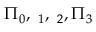Convert formula to latex. <formula><loc_0><loc_0><loc_500><loc_500>\Pi _ { 0 } , { \mathbf \Pi } _ { 1 } , { \mathbf \Pi } _ { 2 } , { \Pi } _ { 3 }</formula> 